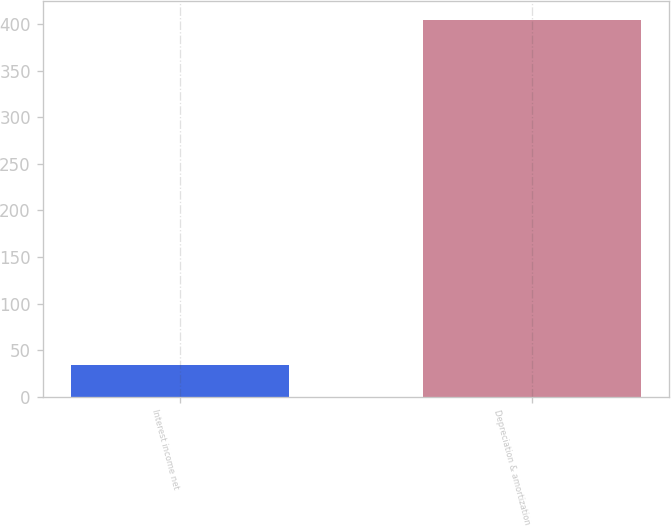Convert chart to OTSL. <chart><loc_0><loc_0><loc_500><loc_500><bar_chart><fcel>Interest income net<fcel>Depreciation & amortization<nl><fcel>34<fcel>404<nl></chart> 